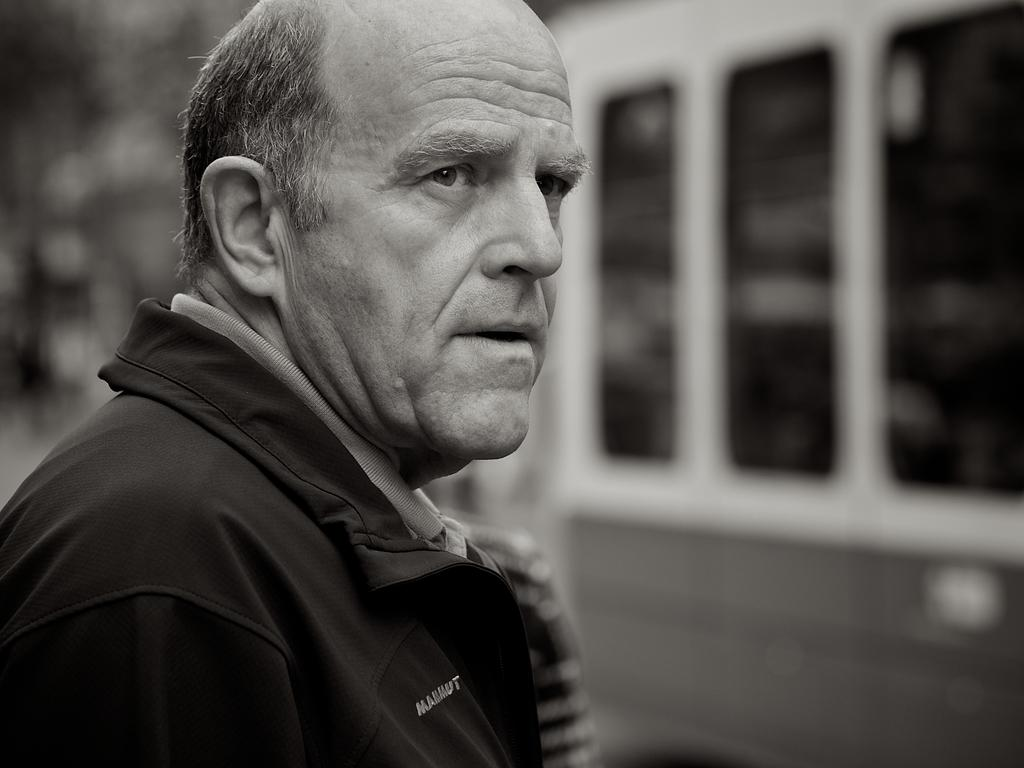What is the main subject of the image? There is a man standing in the image. What is the man wearing? The man is wearing a jacket. What else can be seen on the right side of the image? There is a vehicle on the right side of the image. How many cacti are visible in the image? There are no cacti present in the image. What type of army vehicle can be seen in the image? There is no army vehicle present in the image. 